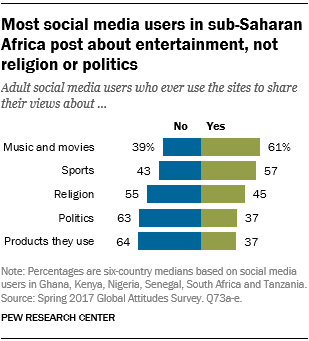Specify some key components in this picture. The color of the bar whose smallest value is 37 is green. There exists at least one pair of green bars that are of similar size. 